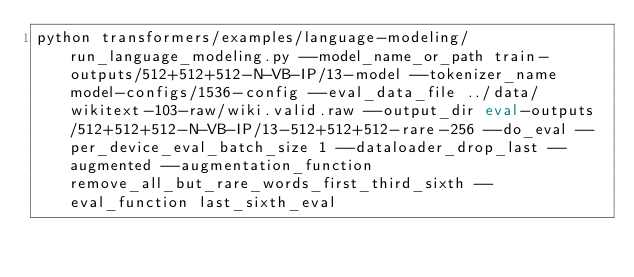<code> <loc_0><loc_0><loc_500><loc_500><_Bash_>python transformers/examples/language-modeling/run_language_modeling.py --model_name_or_path train-outputs/512+512+512-N-VB-IP/13-model --tokenizer_name model-configs/1536-config --eval_data_file ../data/wikitext-103-raw/wiki.valid.raw --output_dir eval-outputs/512+512+512-N-VB-IP/13-512+512+512-rare-256 --do_eval --per_device_eval_batch_size 1 --dataloader_drop_last --augmented --augmentation_function remove_all_but_rare_words_first_third_sixth --eval_function last_sixth_eval</code> 